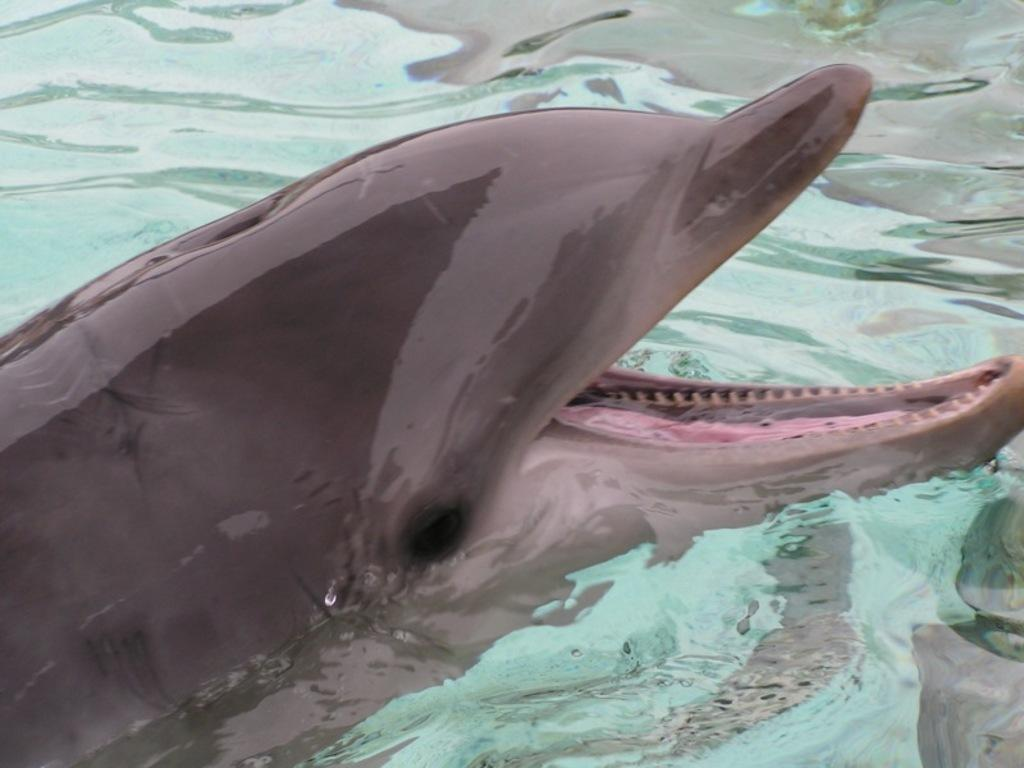What animal is present in the image? There is a dolphin in the image. What is the primary element surrounding the dolphin? There is water visible in the image. What type of bridge can be seen in the image? There is no bridge present in the image; it features a dolphin in water. What does the dolphin's dad look like in the image? Dolphins do not have dads in the traditional sense, and there is no other dolphin or any other creature present in the image to suggest a family relationship. 